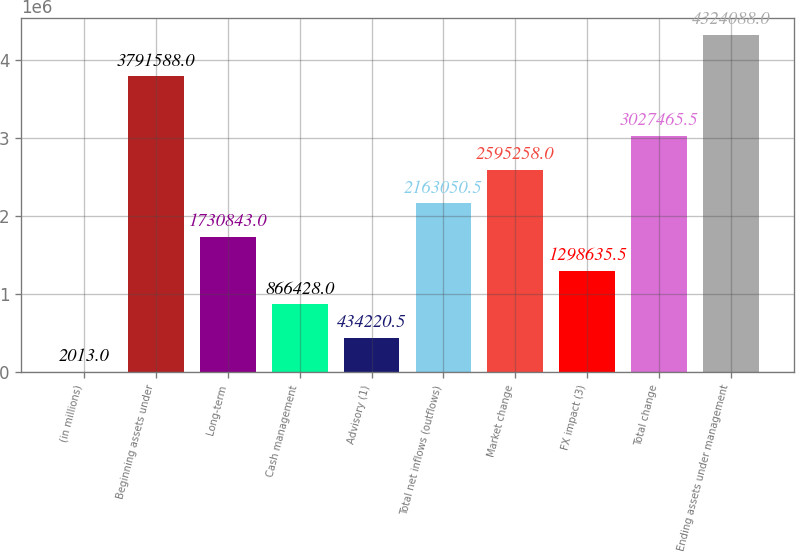Convert chart to OTSL. <chart><loc_0><loc_0><loc_500><loc_500><bar_chart><fcel>(in millions)<fcel>Beginning assets under<fcel>Long-term<fcel>Cash management<fcel>Advisory (1)<fcel>Total net inflows (outflows)<fcel>Market change<fcel>FX impact (3)<fcel>Total change<fcel>Ending assets under management<nl><fcel>2013<fcel>3.79159e+06<fcel>1.73084e+06<fcel>866428<fcel>434220<fcel>2.16305e+06<fcel>2.59526e+06<fcel>1.29864e+06<fcel>3.02747e+06<fcel>4.32409e+06<nl></chart> 